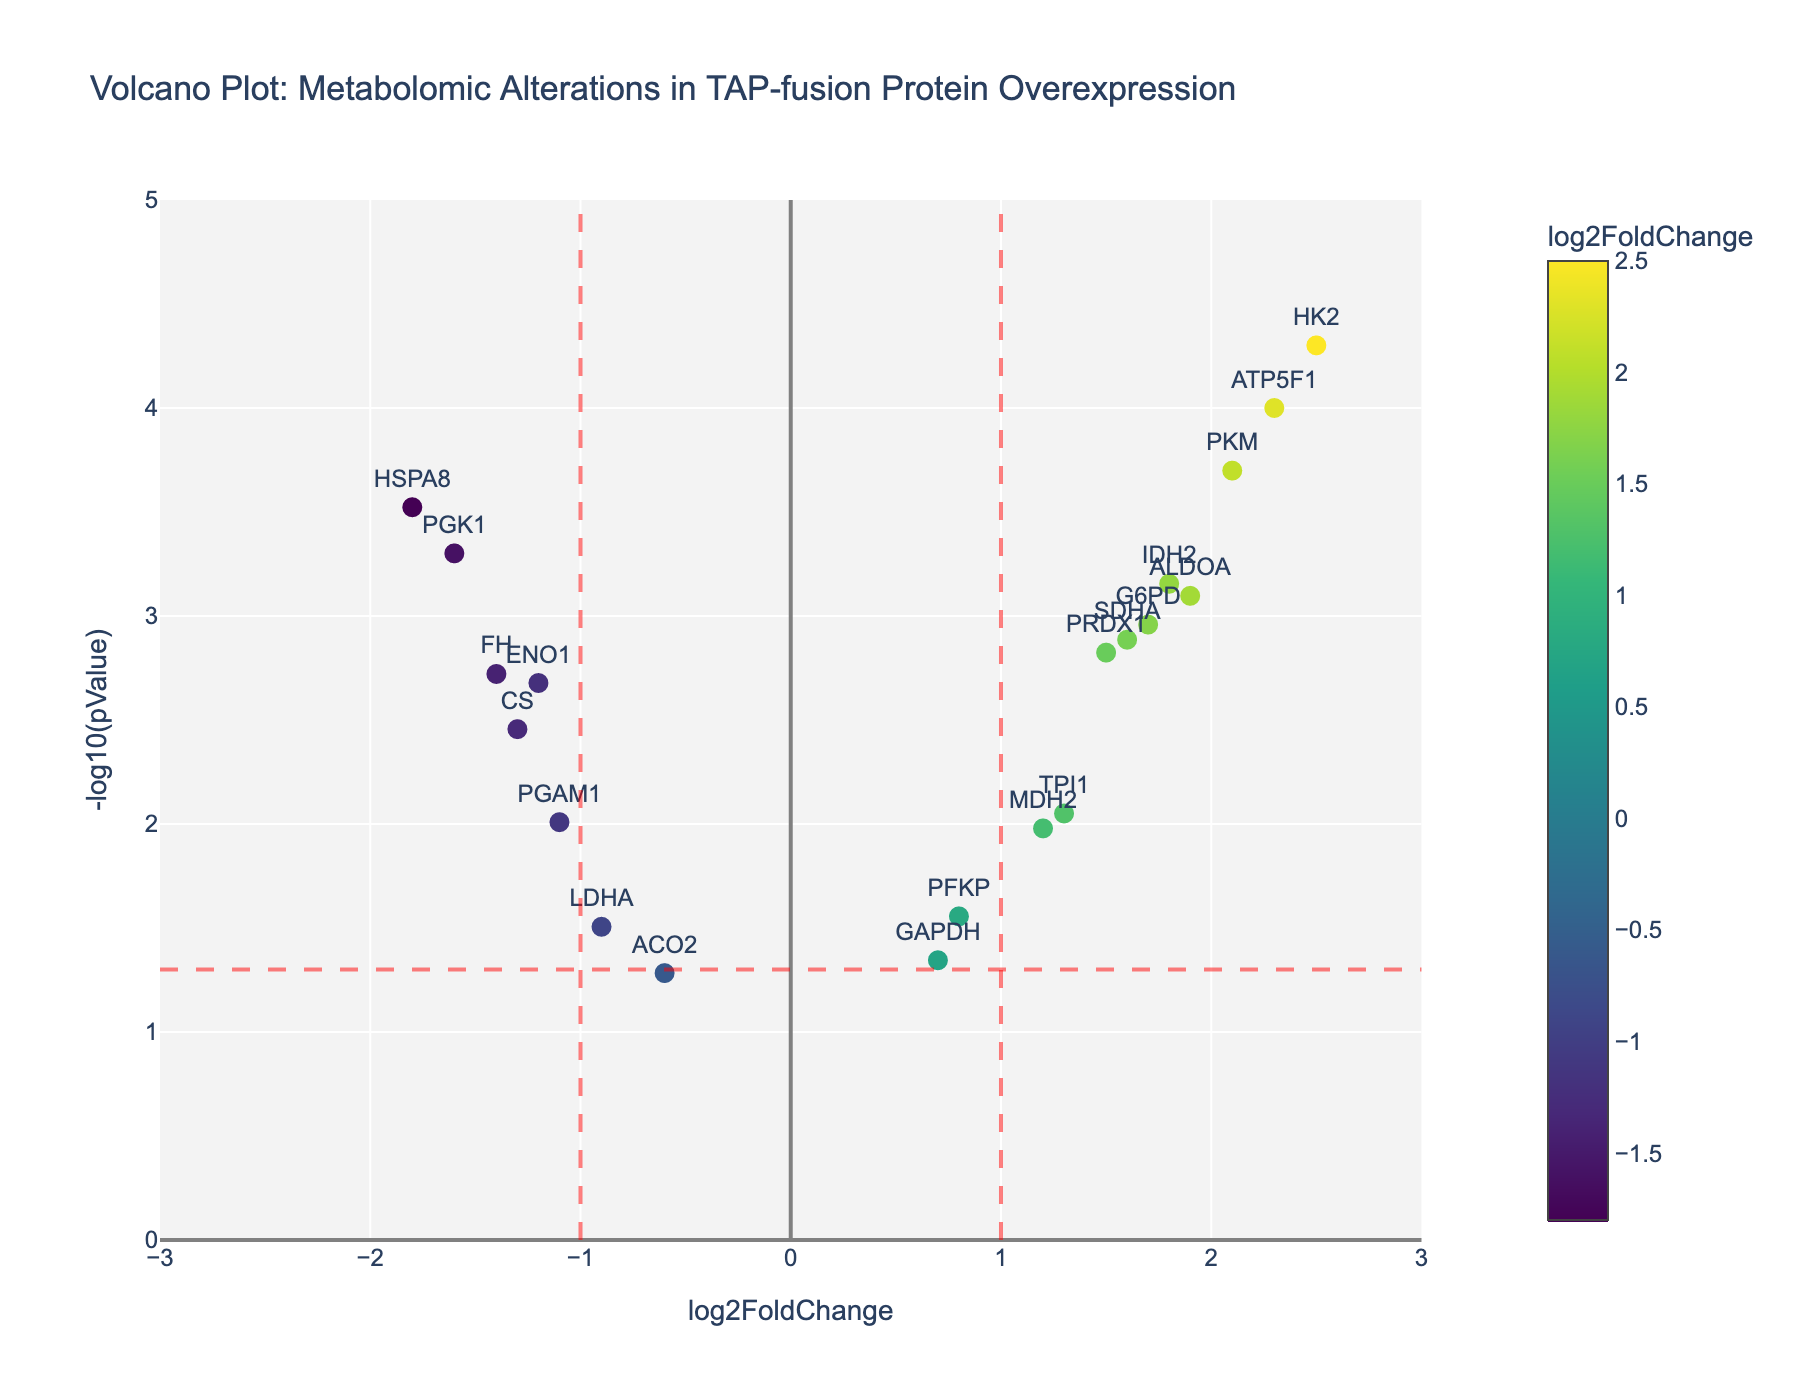Which gene has the highest log2FoldChange? The gene with the highest log2FoldChange can be identified by looking at the x-axis and finding the marker farthest to the right. The gene "HK2" has the highest log2FoldChange of 2.5.
Answer: HK2 What is the significance threshold used in the plot? The significance threshold is represented by the horizontal dashed red line. This line is at y = -log10(0.05), which is approximately 1.3.
Answer: 1.3 How many genes have a log2FoldChange greater than 1 and are statistically significant? To find this, identify dots to the right of the vertical red line at x = 1 and also above the horizontal red line at y = 1.3. The genes ATP5F1, ALDOA, PKM, HK2, IDH2, G6PD, and SDHA meet these criteria.
Answer: 7 Which gene has the lowest p-value? The gene with the lowest p-value will be the one with the highest -log10(pValue) on the y-axis. The gene "HK2" has the highest y-value and thus the lowest p-value.
Answer: HK2 Are there more genes with positive or negative log2FoldChange that are statistically significant? Determine the number of significant genes by counting the markers above the horizontal red line (y = 1.3). There are 8 genes with positive log2FoldChange and 4 genes with negative log2FoldChange.
Answer: More positive (8 vs 4) Which gene has the highest significance among those with a log2FoldChange less than zero? Among the genes with a log2FoldChange less than zero, find the gene with the highest y-axis value. "PGK1" has the highest significance with a p-value of 0.0005 (-log10(pValue) ≈ 3.3).
Answer: PGK1 How many genes have a log2FoldChange between -1 and 1? Count the genes within the range of x-axis values from -1 to 1. Those genes are GAPDH, LDHA, PFKP, ACO2, and SDHA.
Answer: 5 Which gene has a log2FoldChange closest to zero but is still statistically significant? To find the gene with a log2FoldChange close to zero and above the horizontal red line at y = 1.3, look at the markers near the y-axis. GAPDH is closest to zero but it is not above the significance threshold, so the correct genes are ENO1 and PGAM1. ENO1 has a slightly lower log2FoldChange.
Answer: ENO1 